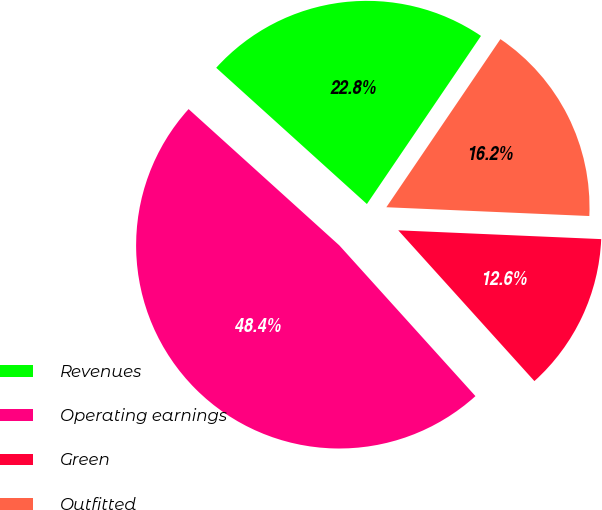Convert chart to OTSL. <chart><loc_0><loc_0><loc_500><loc_500><pie_chart><fcel>Revenues<fcel>Operating earnings<fcel>Green<fcel>Outfitted<nl><fcel>22.79%<fcel>48.39%<fcel>12.62%<fcel>16.2%<nl></chart> 